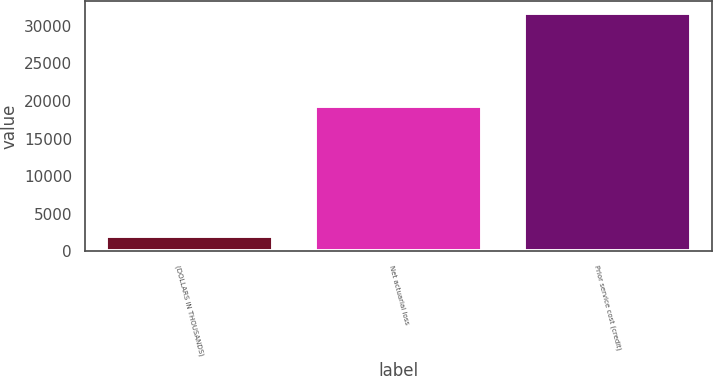<chart> <loc_0><loc_0><loc_500><loc_500><bar_chart><fcel>(DOLLARS IN THOUSANDS)<fcel>Net actuarial loss<fcel>Prior service cost (credit)<nl><fcel>2016<fcel>19336<fcel>31664<nl></chart> 